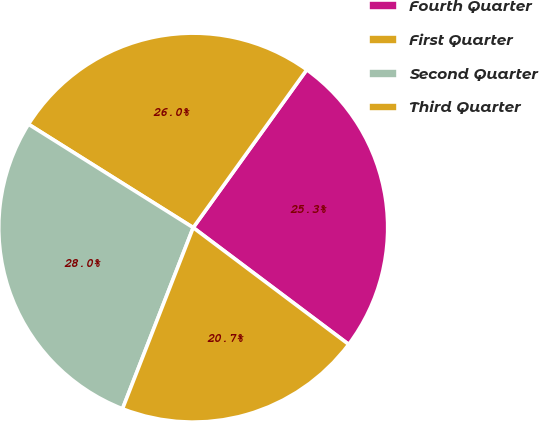<chart> <loc_0><loc_0><loc_500><loc_500><pie_chart><fcel>Fourth Quarter<fcel>First Quarter<fcel>Second Quarter<fcel>Third Quarter<nl><fcel>25.33%<fcel>26.0%<fcel>28.0%<fcel>20.67%<nl></chart> 